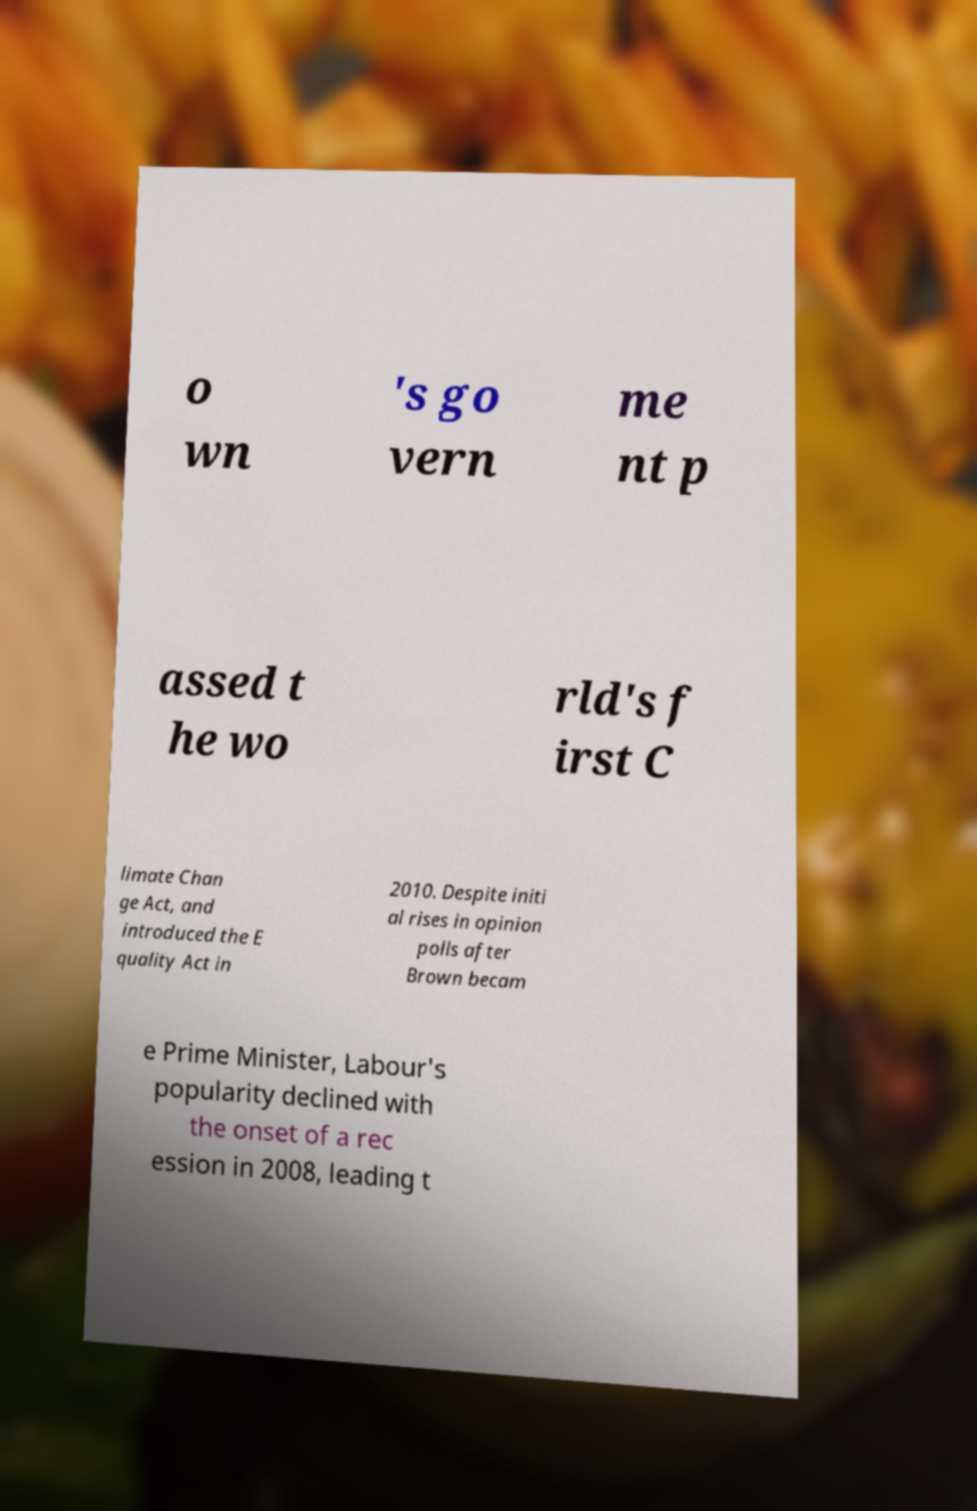Please identify and transcribe the text found in this image. o wn 's go vern me nt p assed t he wo rld's f irst C limate Chan ge Act, and introduced the E quality Act in 2010. Despite initi al rises in opinion polls after Brown becam e Prime Minister, Labour's popularity declined with the onset of a rec ession in 2008, leading t 